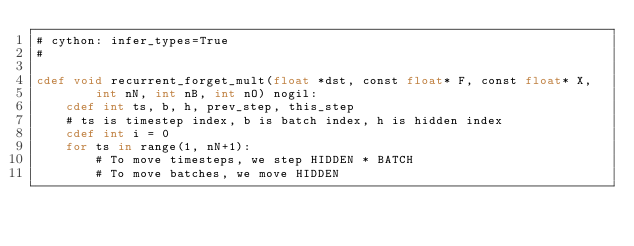Convert code to text. <code><loc_0><loc_0><loc_500><loc_500><_Cython_># cython: infer_types=True
#

cdef void recurrent_forget_mult(float *dst, const float* F, const float* X,
        int nN, int nB, int nO) nogil:
    cdef int ts, b, h, prev_step, this_step
    # ts is timestep index, b is batch index, h is hidden index
    cdef int i = 0
    for ts in range(1, nN+1):
        # To move timesteps, we step HIDDEN * BATCH
        # To move batches, we move HIDDEN</code> 